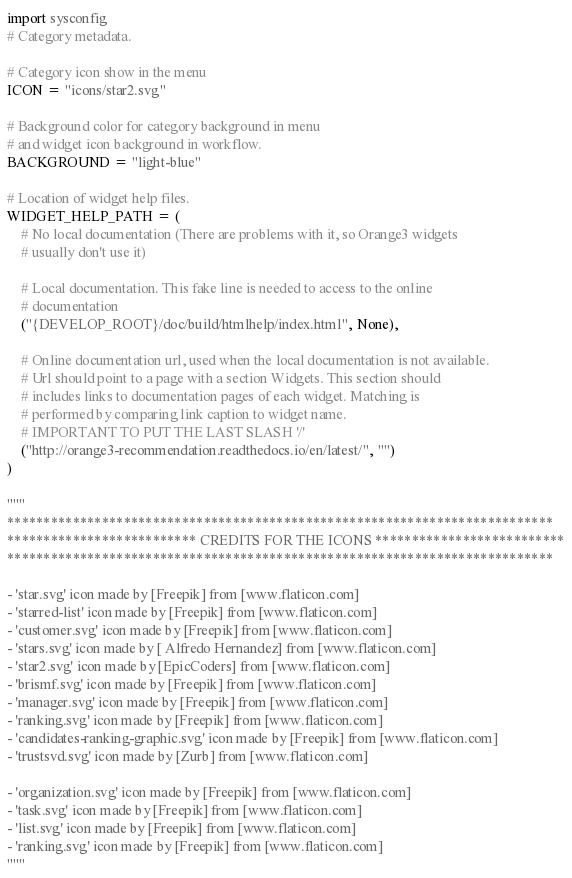Convert code to text. <code><loc_0><loc_0><loc_500><loc_500><_Python_>import sysconfig
# Category metadata.

# Category icon show in the menu
ICON = "icons/star2.svg"

# Background color for category background in menu
# and widget icon background in workflow.
BACKGROUND = "light-blue"

# Location of widget help files.
WIDGET_HELP_PATH = (
    # No local documentation (There are problems with it, so Orange3 widgets
    # usually don't use it)

    # Local documentation. This fake line is needed to access to the online
    # documentation
    ("{DEVELOP_ROOT}/doc/build/htmlhelp/index.html", None),

    # Online documentation url, used when the local documentation is not available.
    # Url should point to a page with a section Widgets. This section should
    # includes links to documentation pages of each widget. Matching is
    # performed by comparing link caption to widget name.
    # IMPORTANT TO PUT THE LAST SLASH '/'
    ("http://orange3-recommendation.readthedocs.io/en/latest/", "")
)

"""
***************************************************************************
************************** CREDITS FOR THE ICONS **************************
***************************************************************************

- 'star.svg' icon made by [Freepik] from [www.flaticon.com]
- 'starred-list' icon made by [Freepik] from [www.flaticon.com]
- 'customer.svg' icon made by [Freepik] from [www.flaticon.com]
- 'stars.svg' icon made by [ Alfredo Hernandez] from [www.flaticon.com]
- 'star2.svg' icon made by [EpicCoders] from [www.flaticon.com]
- 'brismf.svg' icon made by [Freepik] from [www.flaticon.com]
- 'manager.svg' icon made by [Freepik] from [www.flaticon.com]
- 'ranking.svg' icon made by [Freepik] from [www.flaticon.com]
- 'candidates-ranking-graphic.svg' icon made by [Freepik] from [www.flaticon.com]
- 'trustsvd.svg' icon made by [Zurb] from [www.flaticon.com]

- 'organization.svg' icon made by [Freepik] from [www.flaticon.com]
- 'task.svg' icon made by [Freepik] from [www.flaticon.com]
- 'list.svg' icon made by [Freepik] from [www.flaticon.com]
- 'ranking.svg' icon made by [Freepik] from [www.flaticon.com]
"""</code> 